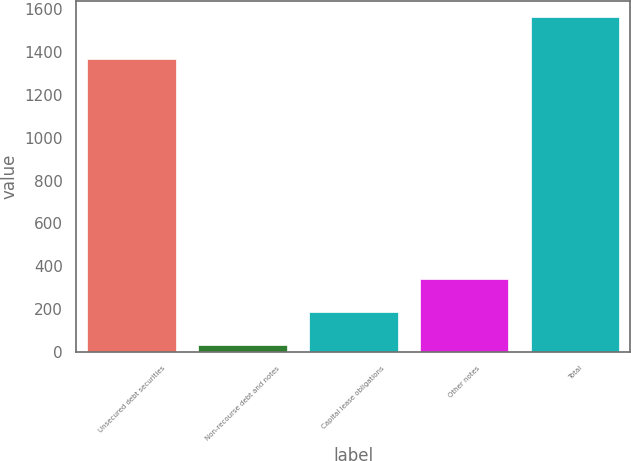<chart> <loc_0><loc_0><loc_500><loc_500><bar_chart><fcel>Unsecured debt securities<fcel>Non-recourse debt and notes<fcel>Capital lease obligations<fcel>Other notes<fcel>Total<nl><fcel>1370<fcel>32<fcel>185.1<fcel>338.2<fcel>1563<nl></chart> 